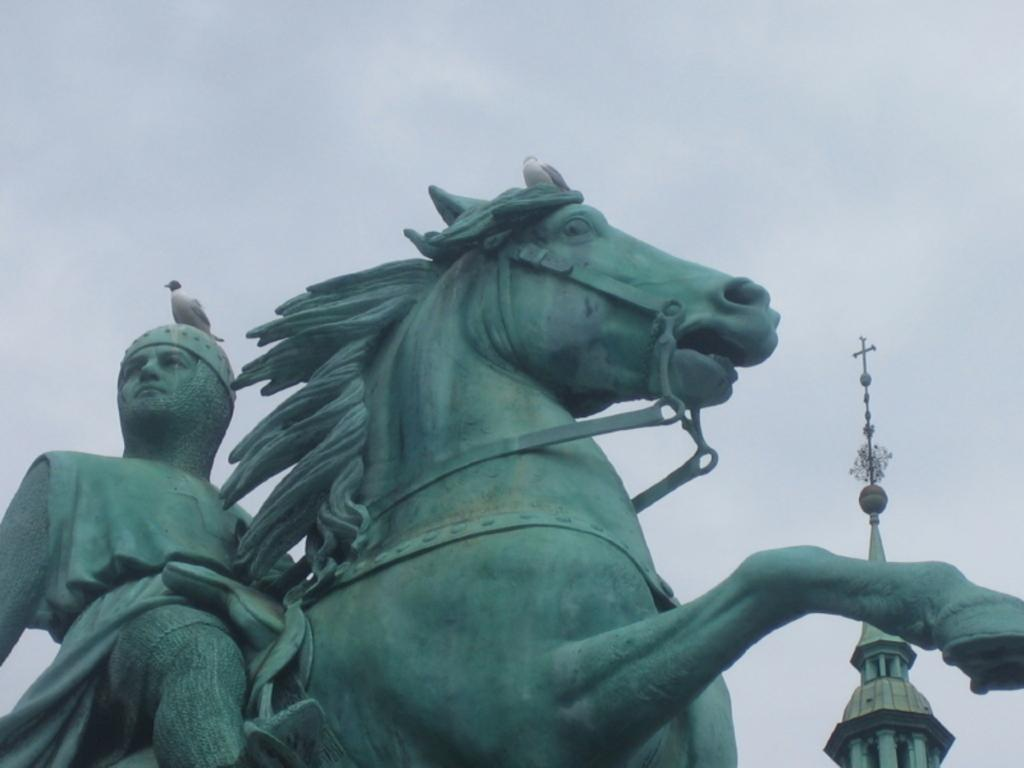What is the main subject of the image? There is a statue of a person and a horse in the image. What can be seen in the background of the image? There is a tower in the background of the image. What is located at the top of the image? There is a bird at the top of the image. What is visible in the sky in the image? There are clouds in the sky. What type of stocking is the person wearing in the image? There is no person wearing stockings in the image, as it features a statue of a person and a horse. 